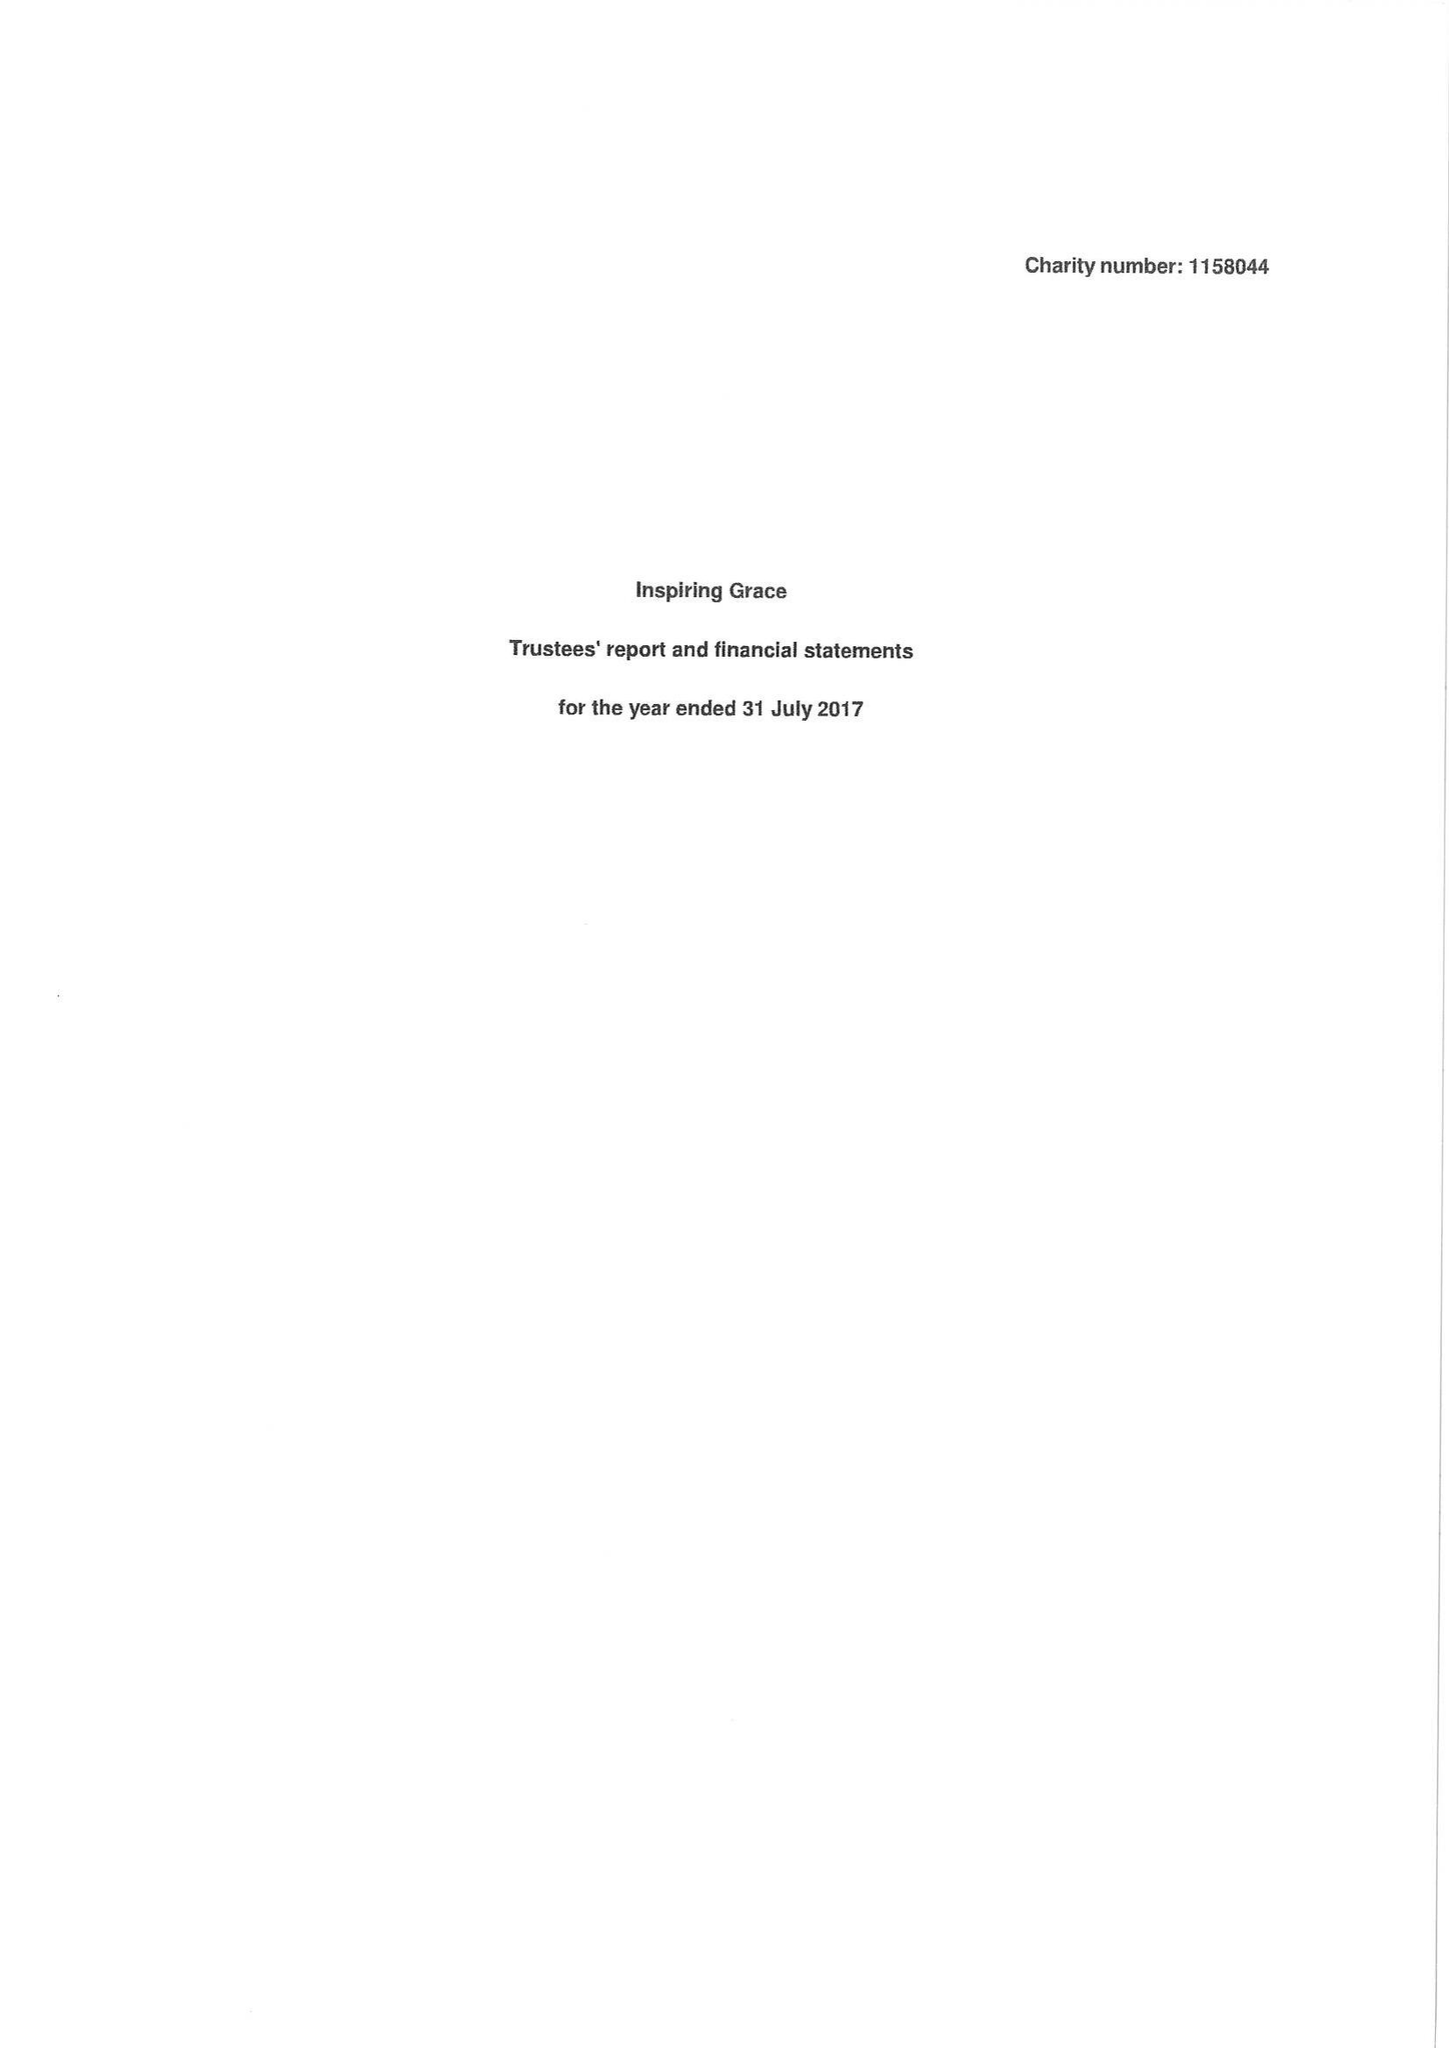What is the value for the charity_number?
Answer the question using a single word or phrase. 1158044 